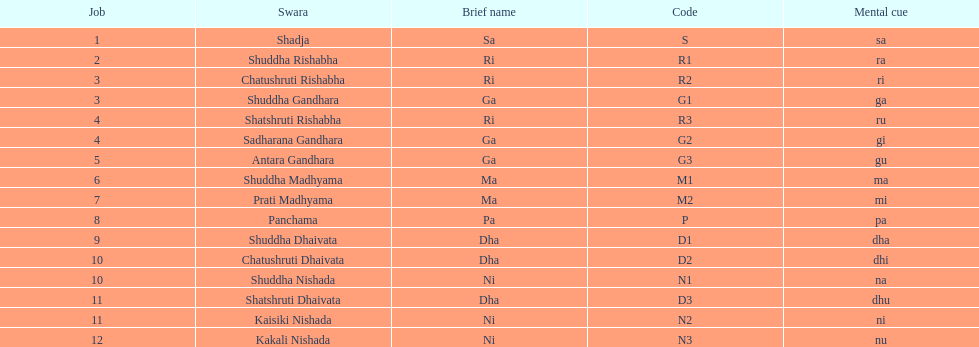On average how many of the swara have a short name that begin with d or g? 6. 